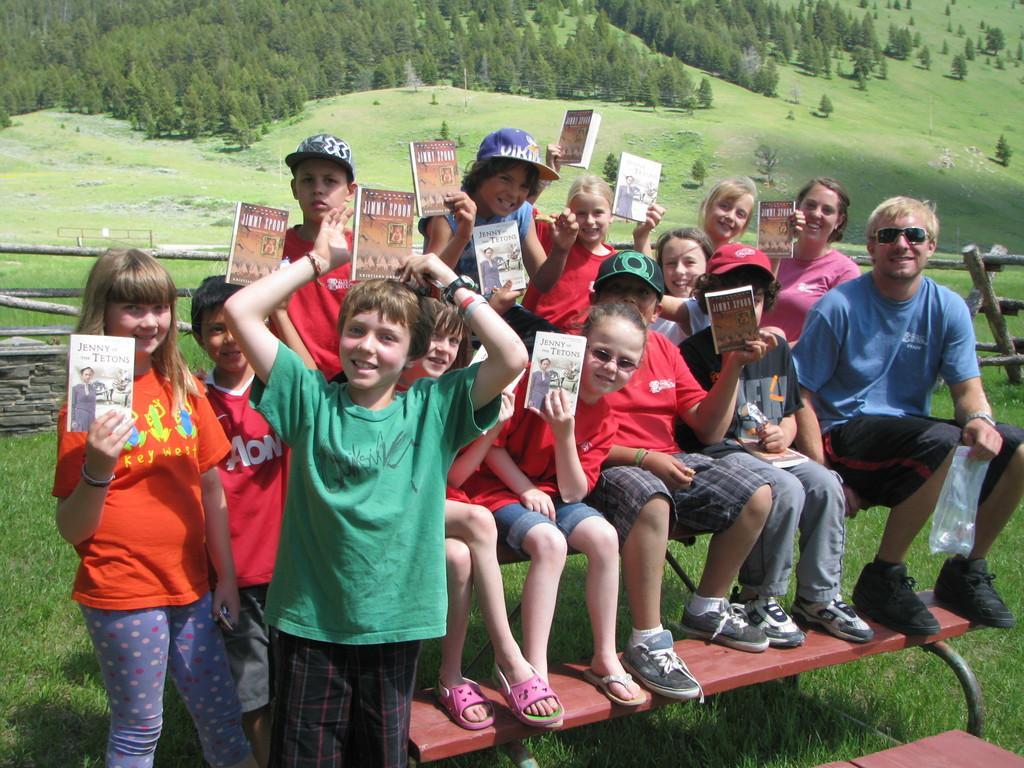Please provide a concise description of this image. There are kids holding books,few kids sitting and this man holding a cover. We can see steps,grass and wooden fence. In the background we can see trees and grass. 